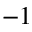Convert formula to latex. <formula><loc_0><loc_0><loc_500><loc_500>^ { - 1 }</formula> 